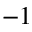Convert formula to latex. <formula><loc_0><loc_0><loc_500><loc_500>^ { - 1 }</formula> 